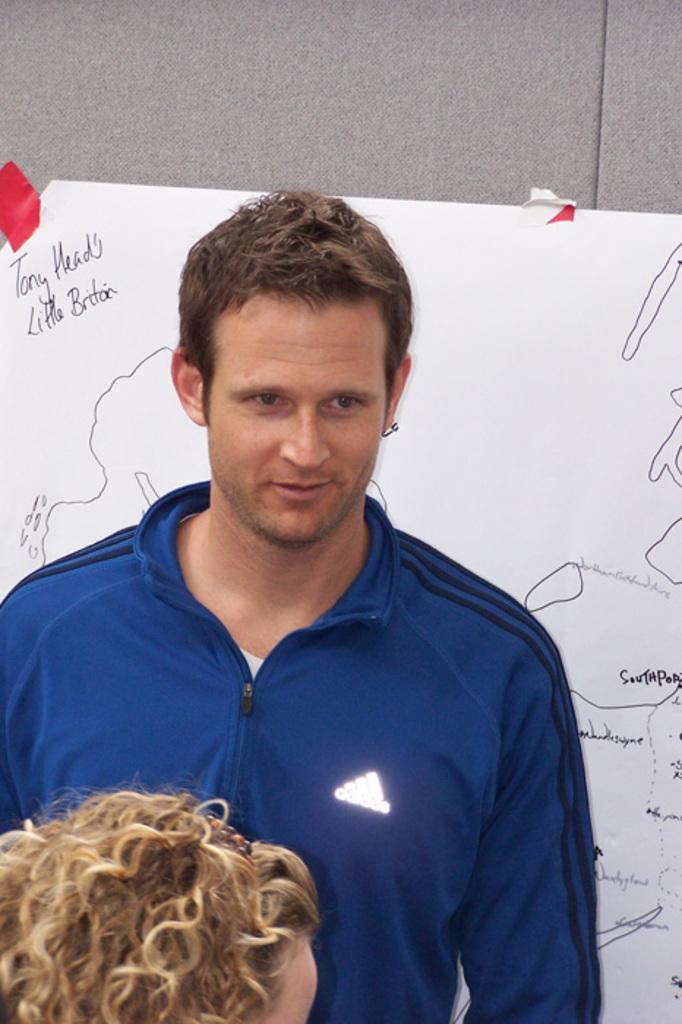Can you describe this image briefly? In this picture there is a man who is wearing blue jacket. He standing near to the board. In the bottom there is a woman who is wearing hairband. At the top there is a wall. 